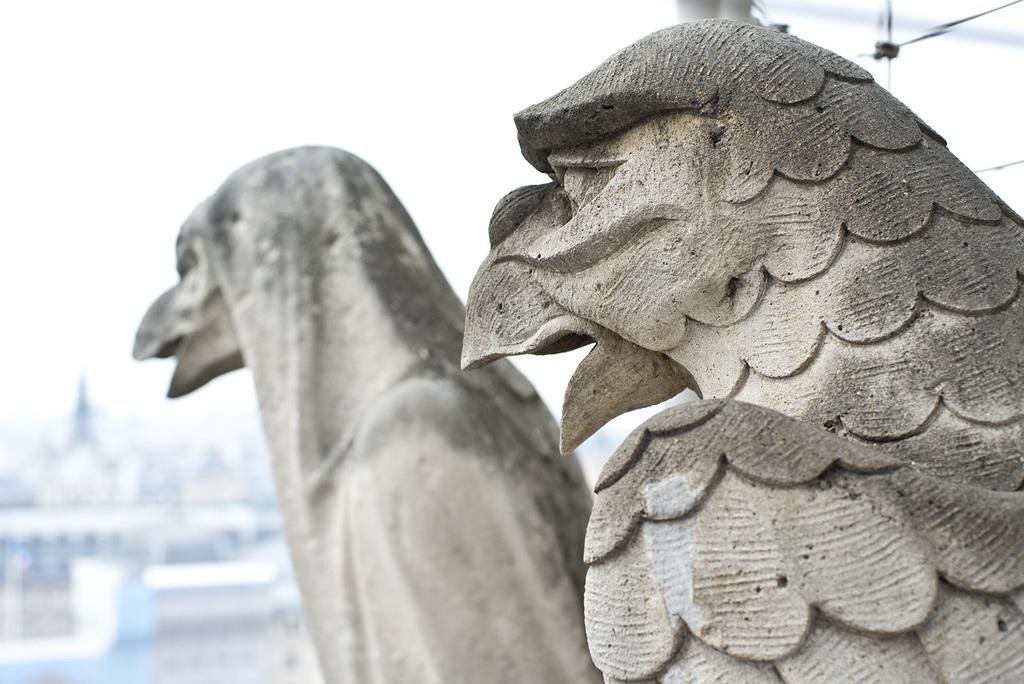What is the main subject in the center of the image? There is a statue in the center of the image. What can be seen in the background of the image? There are buildings and the sky visible in the background of the image. What type of crow is perched on the statue in the image? There is no crow present in the image; it only features a statue, buildings, and the sky. 